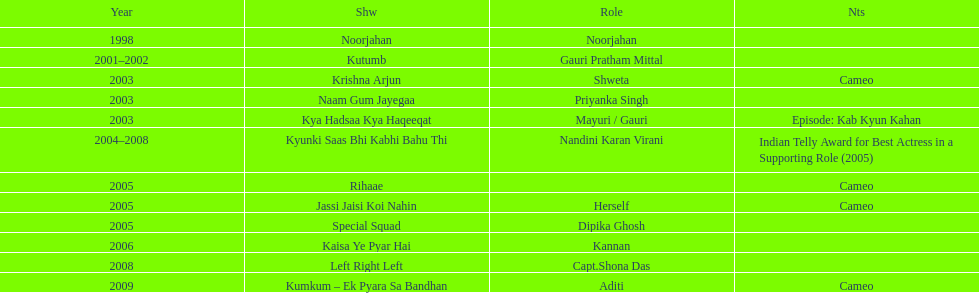In total, how many distinct tv shows has gauri tejwani appeared in or made a cameo in? 11. 